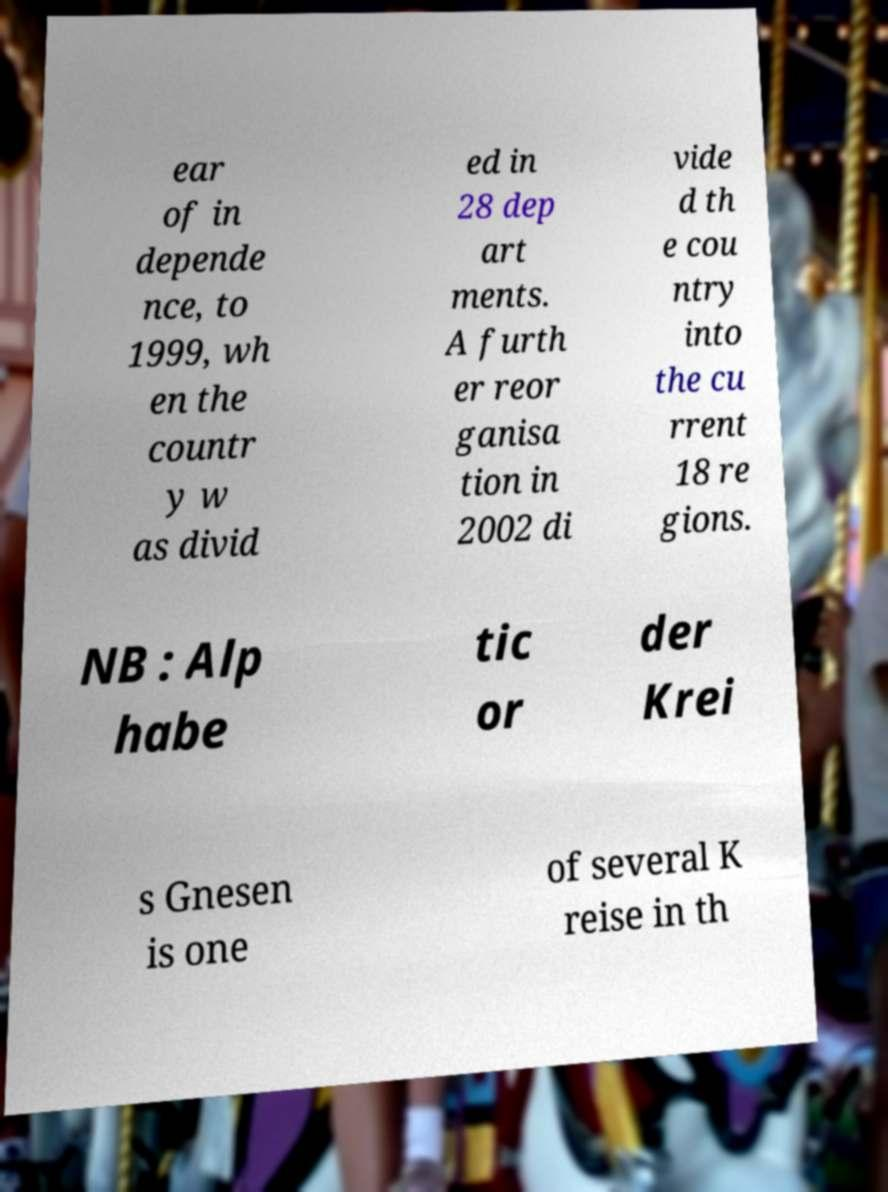There's text embedded in this image that I need extracted. Can you transcribe it verbatim? ear of in depende nce, to 1999, wh en the countr y w as divid ed in 28 dep art ments. A furth er reor ganisa tion in 2002 di vide d th e cou ntry into the cu rrent 18 re gions. NB : Alp habe tic or der Krei s Gnesen is one of several K reise in th 